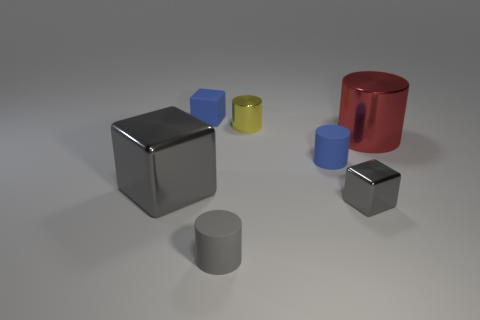Subtract all red cylinders. How many cylinders are left? 3 Subtract all small gray cylinders. How many cylinders are left? 3 Subtract all purple cylinders. Subtract all gray balls. How many cylinders are left? 4 Add 3 red cylinders. How many objects exist? 10 Subtract all cylinders. How many objects are left? 3 Subtract 0 yellow blocks. How many objects are left? 7 Subtract all cubes. Subtract all cubes. How many objects are left? 1 Add 6 tiny gray rubber cylinders. How many tiny gray rubber cylinders are left? 7 Add 4 big red cylinders. How many big red cylinders exist? 5 